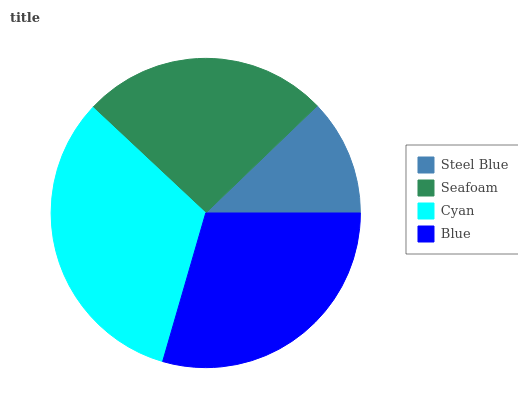Is Steel Blue the minimum?
Answer yes or no. Yes. Is Cyan the maximum?
Answer yes or no. Yes. Is Seafoam the minimum?
Answer yes or no. No. Is Seafoam the maximum?
Answer yes or no. No. Is Seafoam greater than Steel Blue?
Answer yes or no. Yes. Is Steel Blue less than Seafoam?
Answer yes or no. Yes. Is Steel Blue greater than Seafoam?
Answer yes or no. No. Is Seafoam less than Steel Blue?
Answer yes or no. No. Is Blue the high median?
Answer yes or no. Yes. Is Seafoam the low median?
Answer yes or no. Yes. Is Cyan the high median?
Answer yes or no. No. Is Cyan the low median?
Answer yes or no. No. 